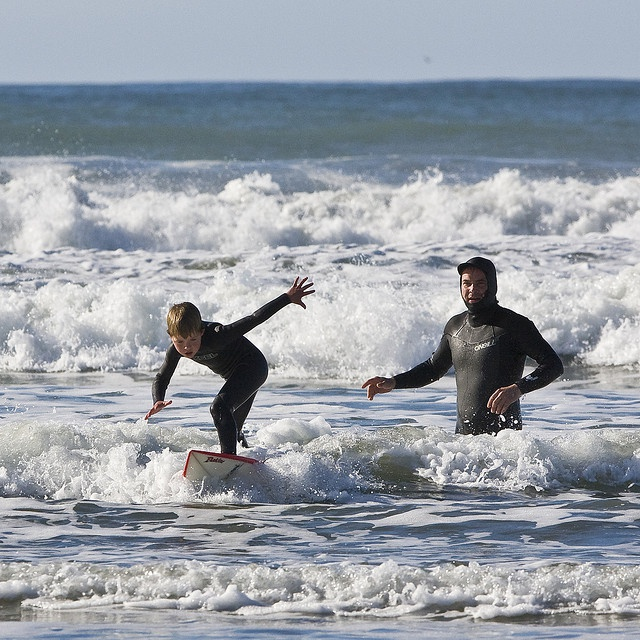Describe the objects in this image and their specific colors. I can see people in darkgray, black, gray, and maroon tones, people in darkgray, black, gray, lightgray, and maroon tones, and surfboard in darkgray, gray, and maroon tones in this image. 